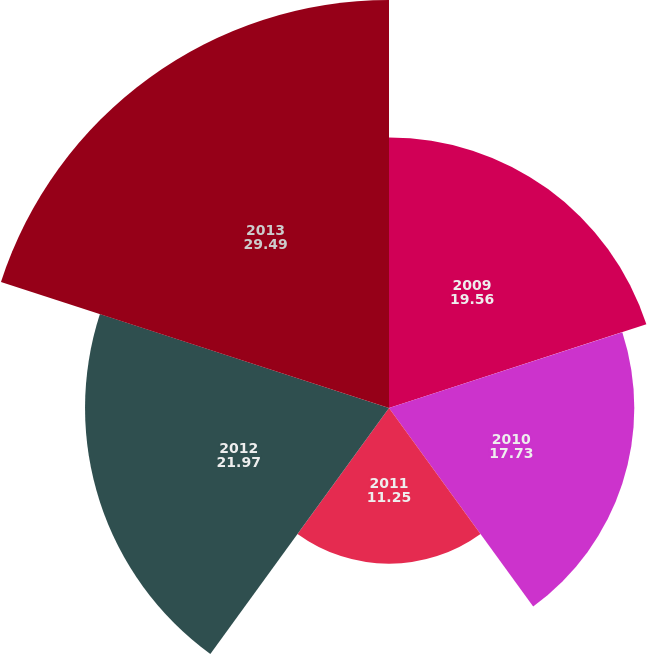Convert chart. <chart><loc_0><loc_0><loc_500><loc_500><pie_chart><fcel>2009<fcel>2010<fcel>2011<fcel>2012<fcel>2013<nl><fcel>19.56%<fcel>17.73%<fcel>11.25%<fcel>21.97%<fcel>29.49%<nl></chart> 